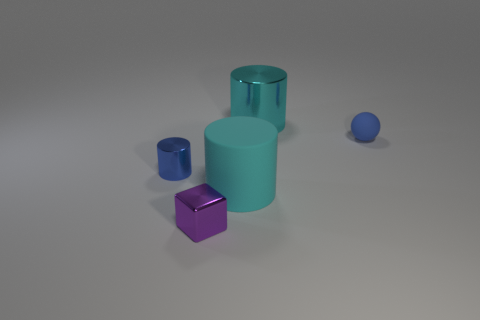Is the big rubber cylinder the same color as the large metal object?
Your response must be concise. Yes. Are there any other things that have the same size as the blue matte ball?
Your answer should be very brief. Yes. What number of blue spheres are in front of the cyan metal cylinder?
Make the answer very short. 1. Are there an equal number of big rubber things left of the tiny matte sphere and small gray rubber cylinders?
Offer a terse response. No. How many objects are either large cyan objects or big gray cubes?
Keep it short and to the point. 2. Are there any other things that are the same shape as the small purple metallic thing?
Make the answer very short. No. There is a big rubber thing right of the blue object that is left of the tiny purple block; what shape is it?
Your answer should be compact. Cylinder. There is a large thing that is the same material as the block; what is its shape?
Offer a terse response. Cylinder. There is a matte object on the right side of the large cyan object that is in front of the small matte ball; what size is it?
Ensure brevity in your answer.  Small. What is the shape of the big cyan matte thing?
Provide a succinct answer. Cylinder. 